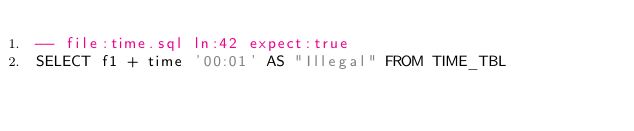<code> <loc_0><loc_0><loc_500><loc_500><_SQL_>-- file:time.sql ln:42 expect:true
SELECT f1 + time '00:01' AS "Illegal" FROM TIME_TBL
</code> 